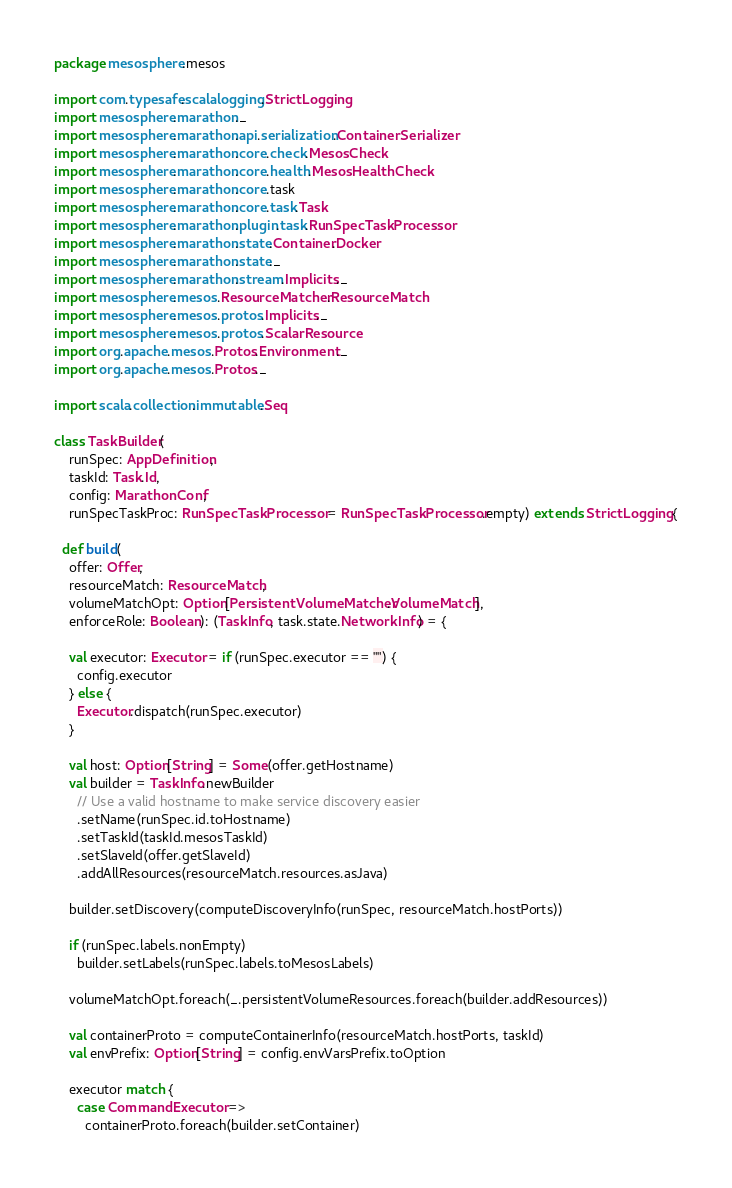Convert code to text. <code><loc_0><loc_0><loc_500><loc_500><_Scala_>package mesosphere.mesos

import com.typesafe.scalalogging.StrictLogging
import mesosphere.marathon._
import mesosphere.marathon.api.serialization.ContainerSerializer
import mesosphere.marathon.core.check.MesosCheck
import mesosphere.marathon.core.health.MesosHealthCheck
import mesosphere.marathon.core.task
import mesosphere.marathon.core.task.Task
import mesosphere.marathon.plugin.task.RunSpecTaskProcessor
import mesosphere.marathon.state.Container.Docker
import mesosphere.marathon.state._
import mesosphere.marathon.stream.Implicits._
import mesosphere.mesos.ResourceMatcher.ResourceMatch
import mesosphere.mesos.protos.Implicits._
import mesosphere.mesos.protos.ScalarResource
import org.apache.mesos.Protos.Environment._
import org.apache.mesos.Protos._

import scala.collection.immutable.Seq

class TaskBuilder(
    runSpec: AppDefinition,
    taskId: Task.Id,
    config: MarathonConf,
    runSpecTaskProc: RunSpecTaskProcessor = RunSpecTaskProcessor.empty) extends StrictLogging {

  def build(
    offer: Offer,
    resourceMatch: ResourceMatch,
    volumeMatchOpt: Option[PersistentVolumeMatcher.VolumeMatch],
    enforceRole: Boolean): (TaskInfo, task.state.NetworkInfo) = {

    val executor: Executor = if (runSpec.executor == "") {
      config.executor
    } else {
      Executor.dispatch(runSpec.executor)
    }

    val host: Option[String] = Some(offer.getHostname)
    val builder = TaskInfo.newBuilder
      // Use a valid hostname to make service discovery easier
      .setName(runSpec.id.toHostname)
      .setTaskId(taskId.mesosTaskId)
      .setSlaveId(offer.getSlaveId)
      .addAllResources(resourceMatch.resources.asJava)

    builder.setDiscovery(computeDiscoveryInfo(runSpec, resourceMatch.hostPorts))

    if (runSpec.labels.nonEmpty)
      builder.setLabels(runSpec.labels.toMesosLabels)

    volumeMatchOpt.foreach(_.persistentVolumeResources.foreach(builder.addResources))

    val containerProto = computeContainerInfo(resourceMatch.hostPorts, taskId)
    val envPrefix: Option[String] = config.envVarsPrefix.toOption

    executor match {
      case CommandExecutor =>
        containerProto.foreach(builder.setContainer)</code> 